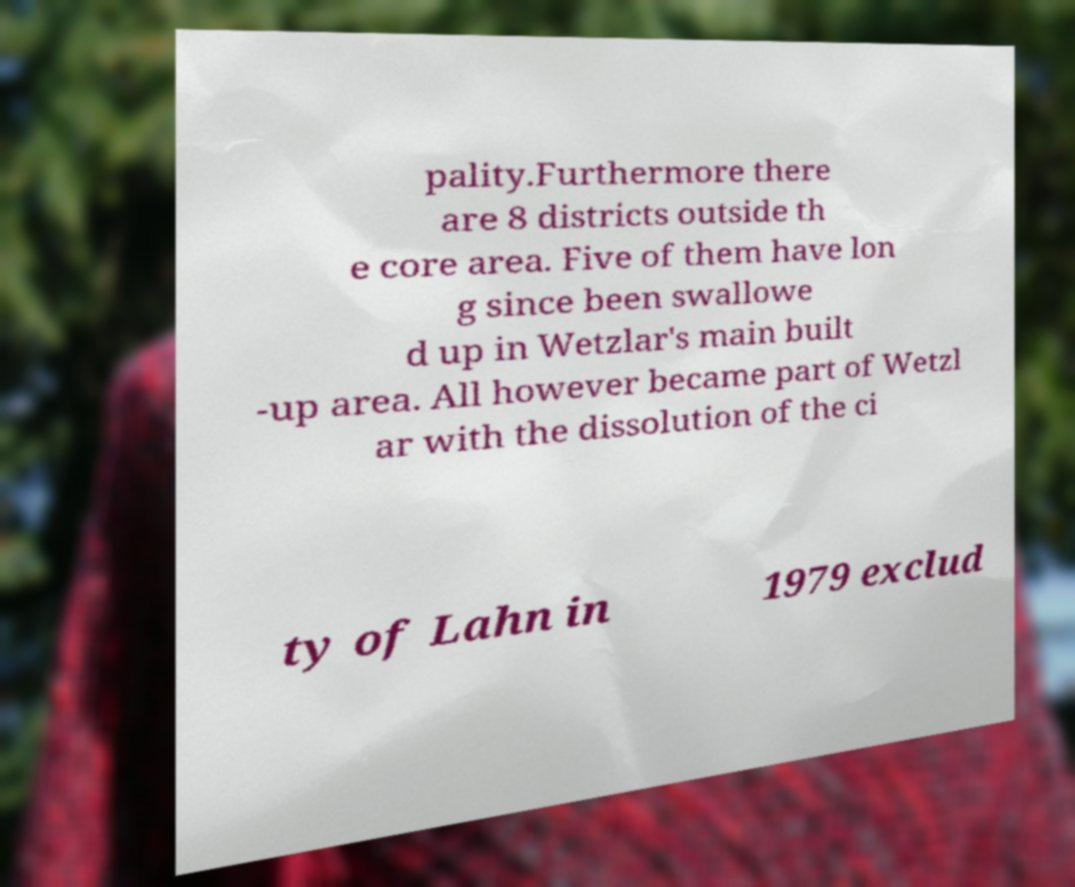There's text embedded in this image that I need extracted. Can you transcribe it verbatim? pality.Furthermore there are 8 districts outside th e core area. Five of them have lon g since been swallowe d up in Wetzlar's main built -up area. All however became part of Wetzl ar with the dissolution of the ci ty of Lahn in 1979 exclud 